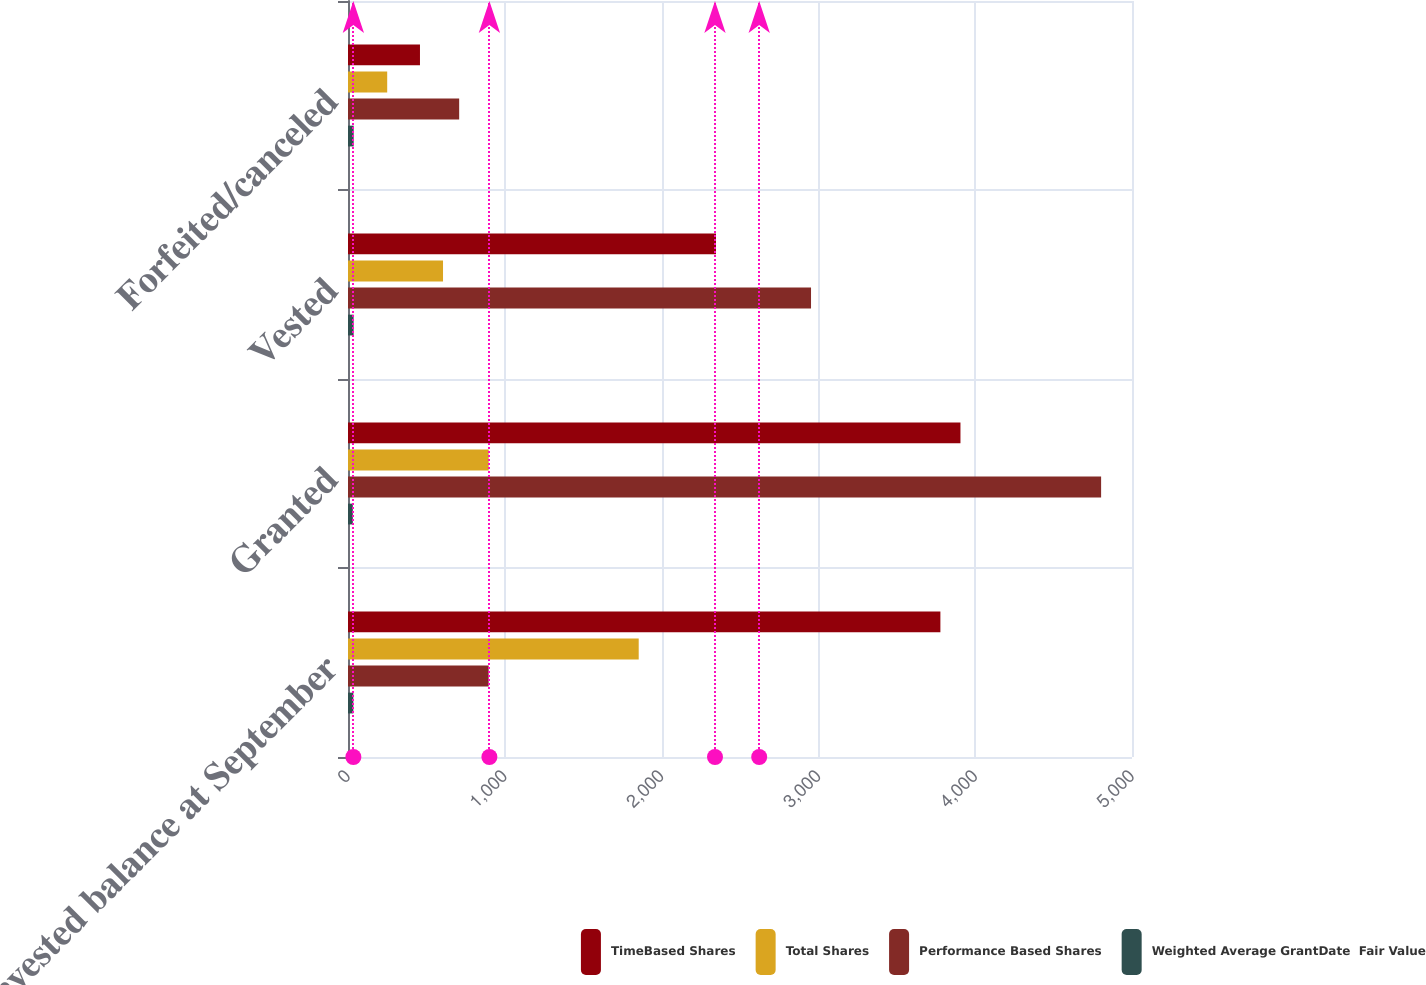Convert chart. <chart><loc_0><loc_0><loc_500><loc_500><stacked_bar_chart><ecel><fcel>Nonvested balance at September<fcel>Granted<fcel>Vested<fcel>Forfeited/canceled<nl><fcel>TimeBased Shares<fcel>3778<fcel>3906<fcel>2347<fcel>459<nl><fcel>Total Shares<fcel>1854<fcel>897<fcel>606<fcel>250<nl><fcel>Performance Based Shares<fcel>897<fcel>4803<fcel>2953<fcel>709<nl><fcel>Weighted Average GrantDate  Fair Value<fcel>34.06<fcel>30.75<fcel>35.8<fcel>36.23<nl></chart> 